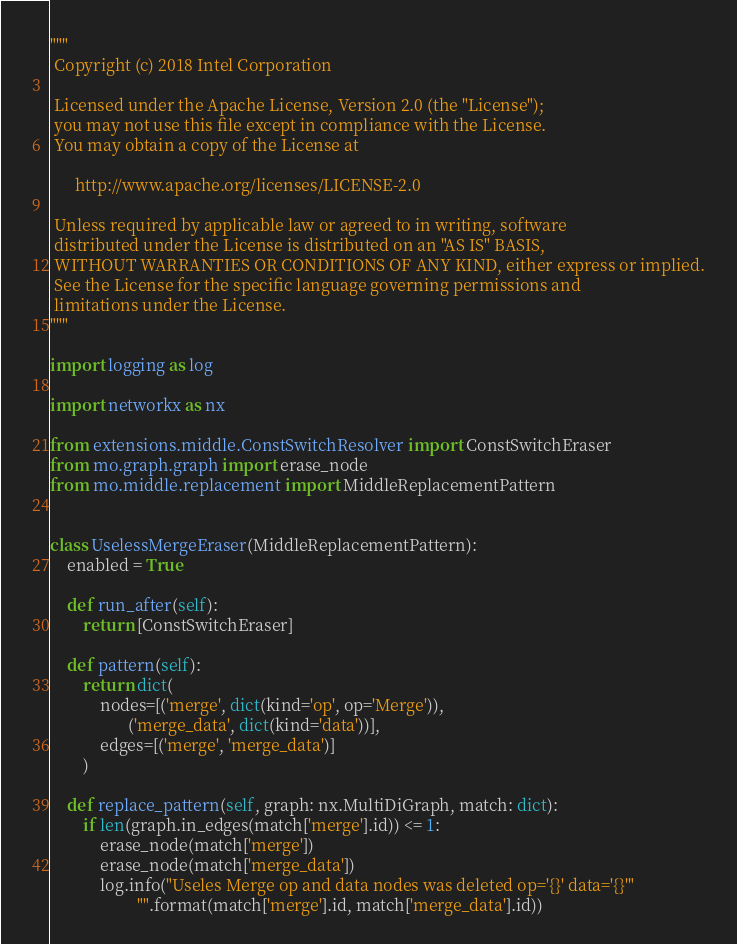Convert code to text. <code><loc_0><loc_0><loc_500><loc_500><_Python_>"""
 Copyright (c) 2018 Intel Corporation

 Licensed under the Apache License, Version 2.0 (the "License");
 you may not use this file except in compliance with the License.
 You may obtain a copy of the License at

      http://www.apache.org/licenses/LICENSE-2.0

 Unless required by applicable law or agreed to in writing, software
 distributed under the License is distributed on an "AS IS" BASIS,
 WITHOUT WARRANTIES OR CONDITIONS OF ANY KIND, either express or implied.
 See the License for the specific language governing permissions and
 limitations under the License.
"""

import logging as log

import networkx as nx

from extensions.middle.ConstSwitchResolver import ConstSwitchEraser
from mo.graph.graph import erase_node
from mo.middle.replacement import MiddleReplacementPattern


class UselessMergeEraser(MiddleReplacementPattern):
    enabled = True

    def run_after(self):
        return [ConstSwitchEraser]

    def pattern(self):
        return dict(
            nodes=[('merge', dict(kind='op', op='Merge')),
                   ('merge_data', dict(kind='data'))],
            edges=[('merge', 'merge_data')]
        )

    def replace_pattern(self, graph: nx.MultiDiGraph, match: dict):
        if len(graph.in_edges(match['merge'].id)) <= 1:
            erase_node(match['merge'])
            erase_node(match['merge_data'])
            log.info("Useles Merge op and data nodes was deleted op='{}' data='{}'"
                     "".format(match['merge'].id, match['merge_data'].id))
</code> 